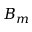Convert formula to latex. <formula><loc_0><loc_0><loc_500><loc_500>B _ { m }</formula> 